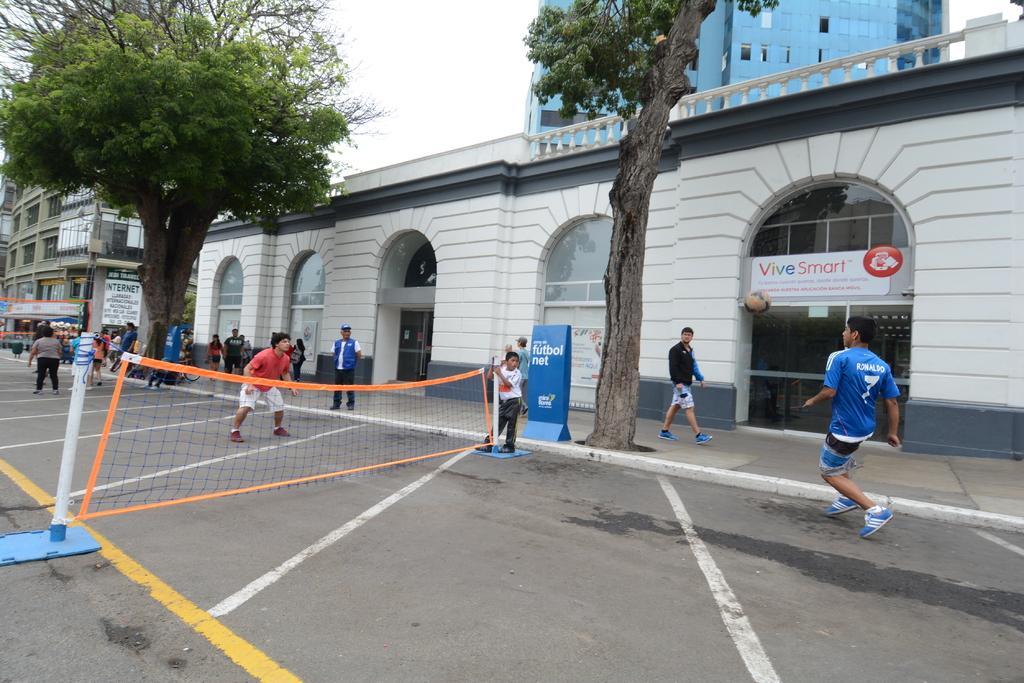Describe this image in one or two sentences. In the picture I can see people standing on the ground. I can also see a net, buildings, trees and some other things. In the background I can see the sky. 